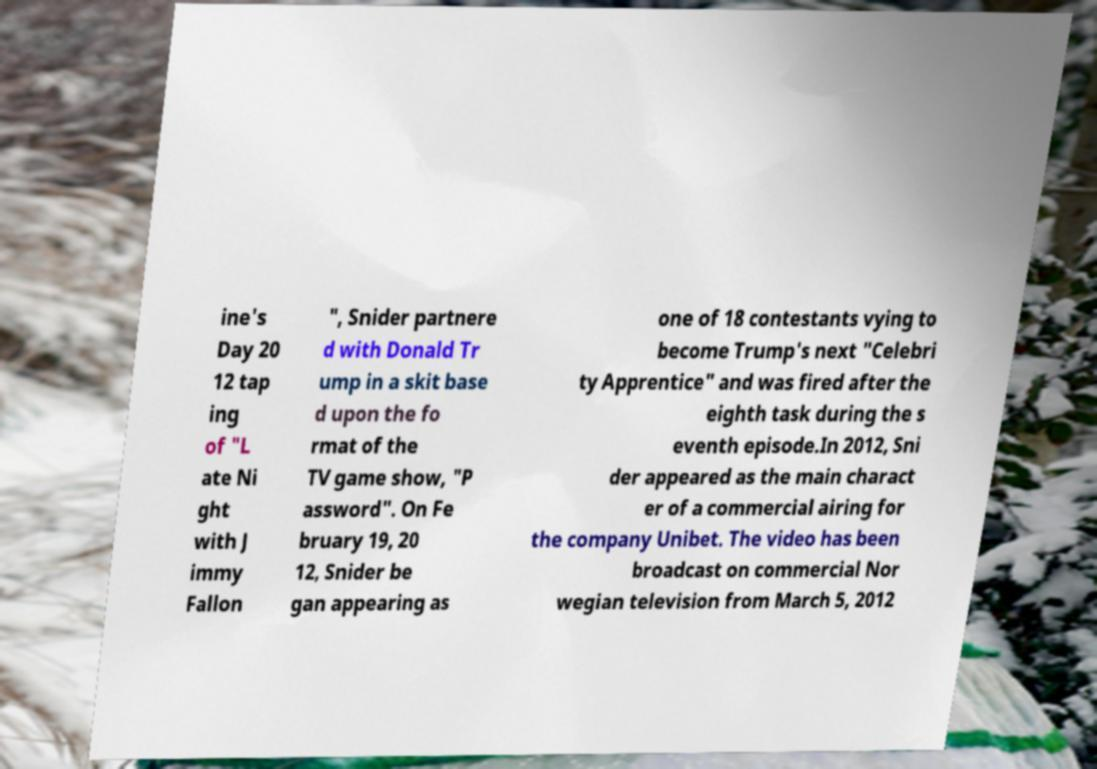Could you extract and type out the text from this image? ine's Day 20 12 tap ing of "L ate Ni ght with J immy Fallon ", Snider partnere d with Donald Tr ump in a skit base d upon the fo rmat of the TV game show, "P assword". On Fe bruary 19, 20 12, Snider be gan appearing as one of 18 contestants vying to become Trump's next "Celebri ty Apprentice" and was fired after the eighth task during the s eventh episode.In 2012, Sni der appeared as the main charact er of a commercial airing for the company Unibet. The video has been broadcast on commercial Nor wegian television from March 5, 2012 